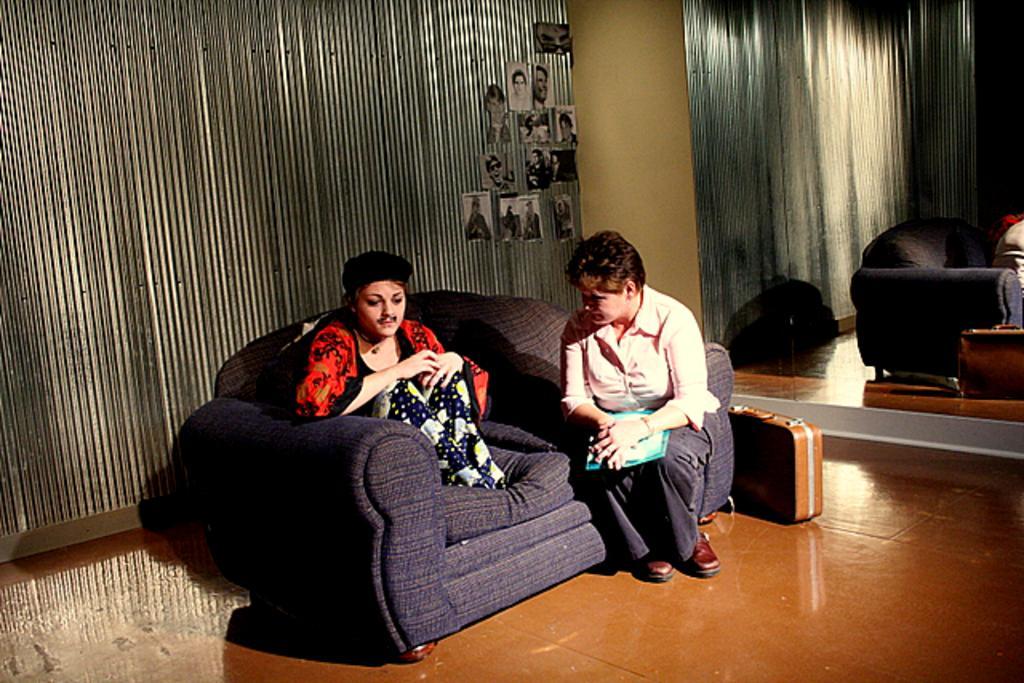Please provide a concise description of this image. In this image there are 2 persons sitting in couch and talking to each other ,and at the back ground there is a briefcase , mirror, wall, some photos stick to the wall. 